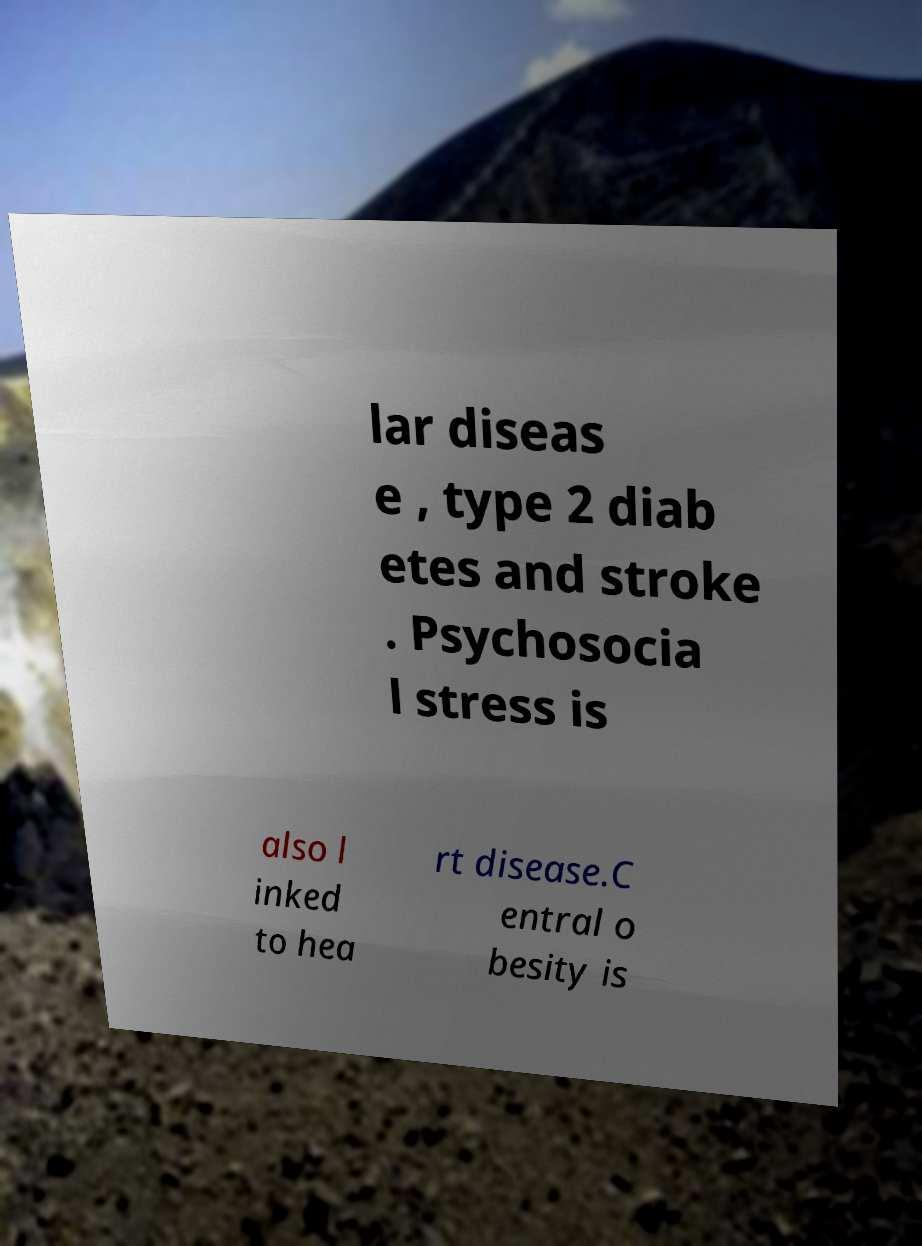I need the written content from this picture converted into text. Can you do that? lar diseas e , type 2 diab etes and stroke . Psychosocia l stress is also l inked to hea rt disease.C entral o besity is 